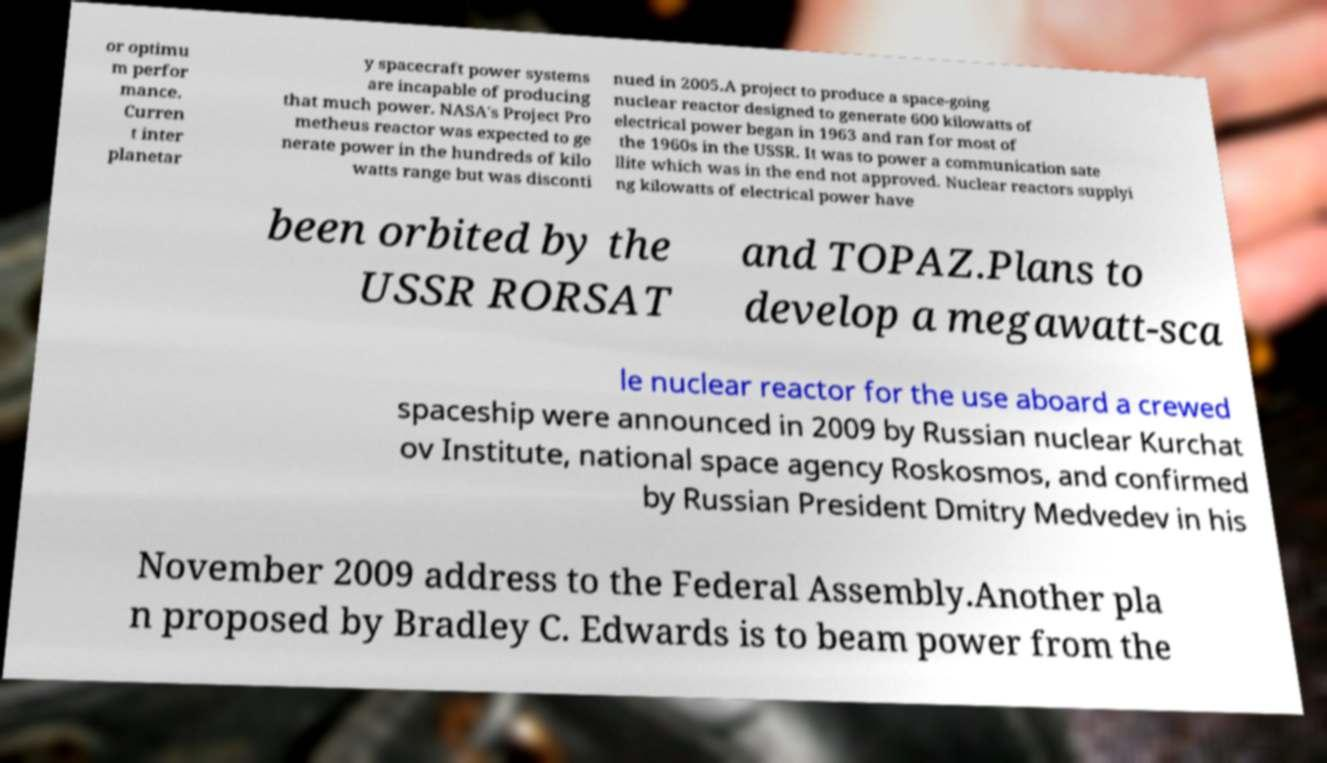There's text embedded in this image that I need extracted. Can you transcribe it verbatim? or optimu m perfor mance. Curren t inter planetar y spacecraft power systems are incapable of producing that much power. NASA's Project Pro metheus reactor was expected to ge nerate power in the hundreds of kilo watts range but was disconti nued in 2005.A project to produce a space-going nuclear reactor designed to generate 600 kilowatts of electrical power began in 1963 and ran for most of the 1960s in the USSR. It was to power a communication sate llite which was in the end not approved. Nuclear reactors supplyi ng kilowatts of electrical power have been orbited by the USSR RORSAT and TOPAZ.Plans to develop a megawatt-sca le nuclear reactor for the use aboard a crewed spaceship were announced in 2009 by Russian nuclear Kurchat ov Institute, national space agency Roskosmos, and confirmed by Russian President Dmitry Medvedev in his November 2009 address to the Federal Assembly.Another pla n proposed by Bradley C. Edwards is to beam power from the 